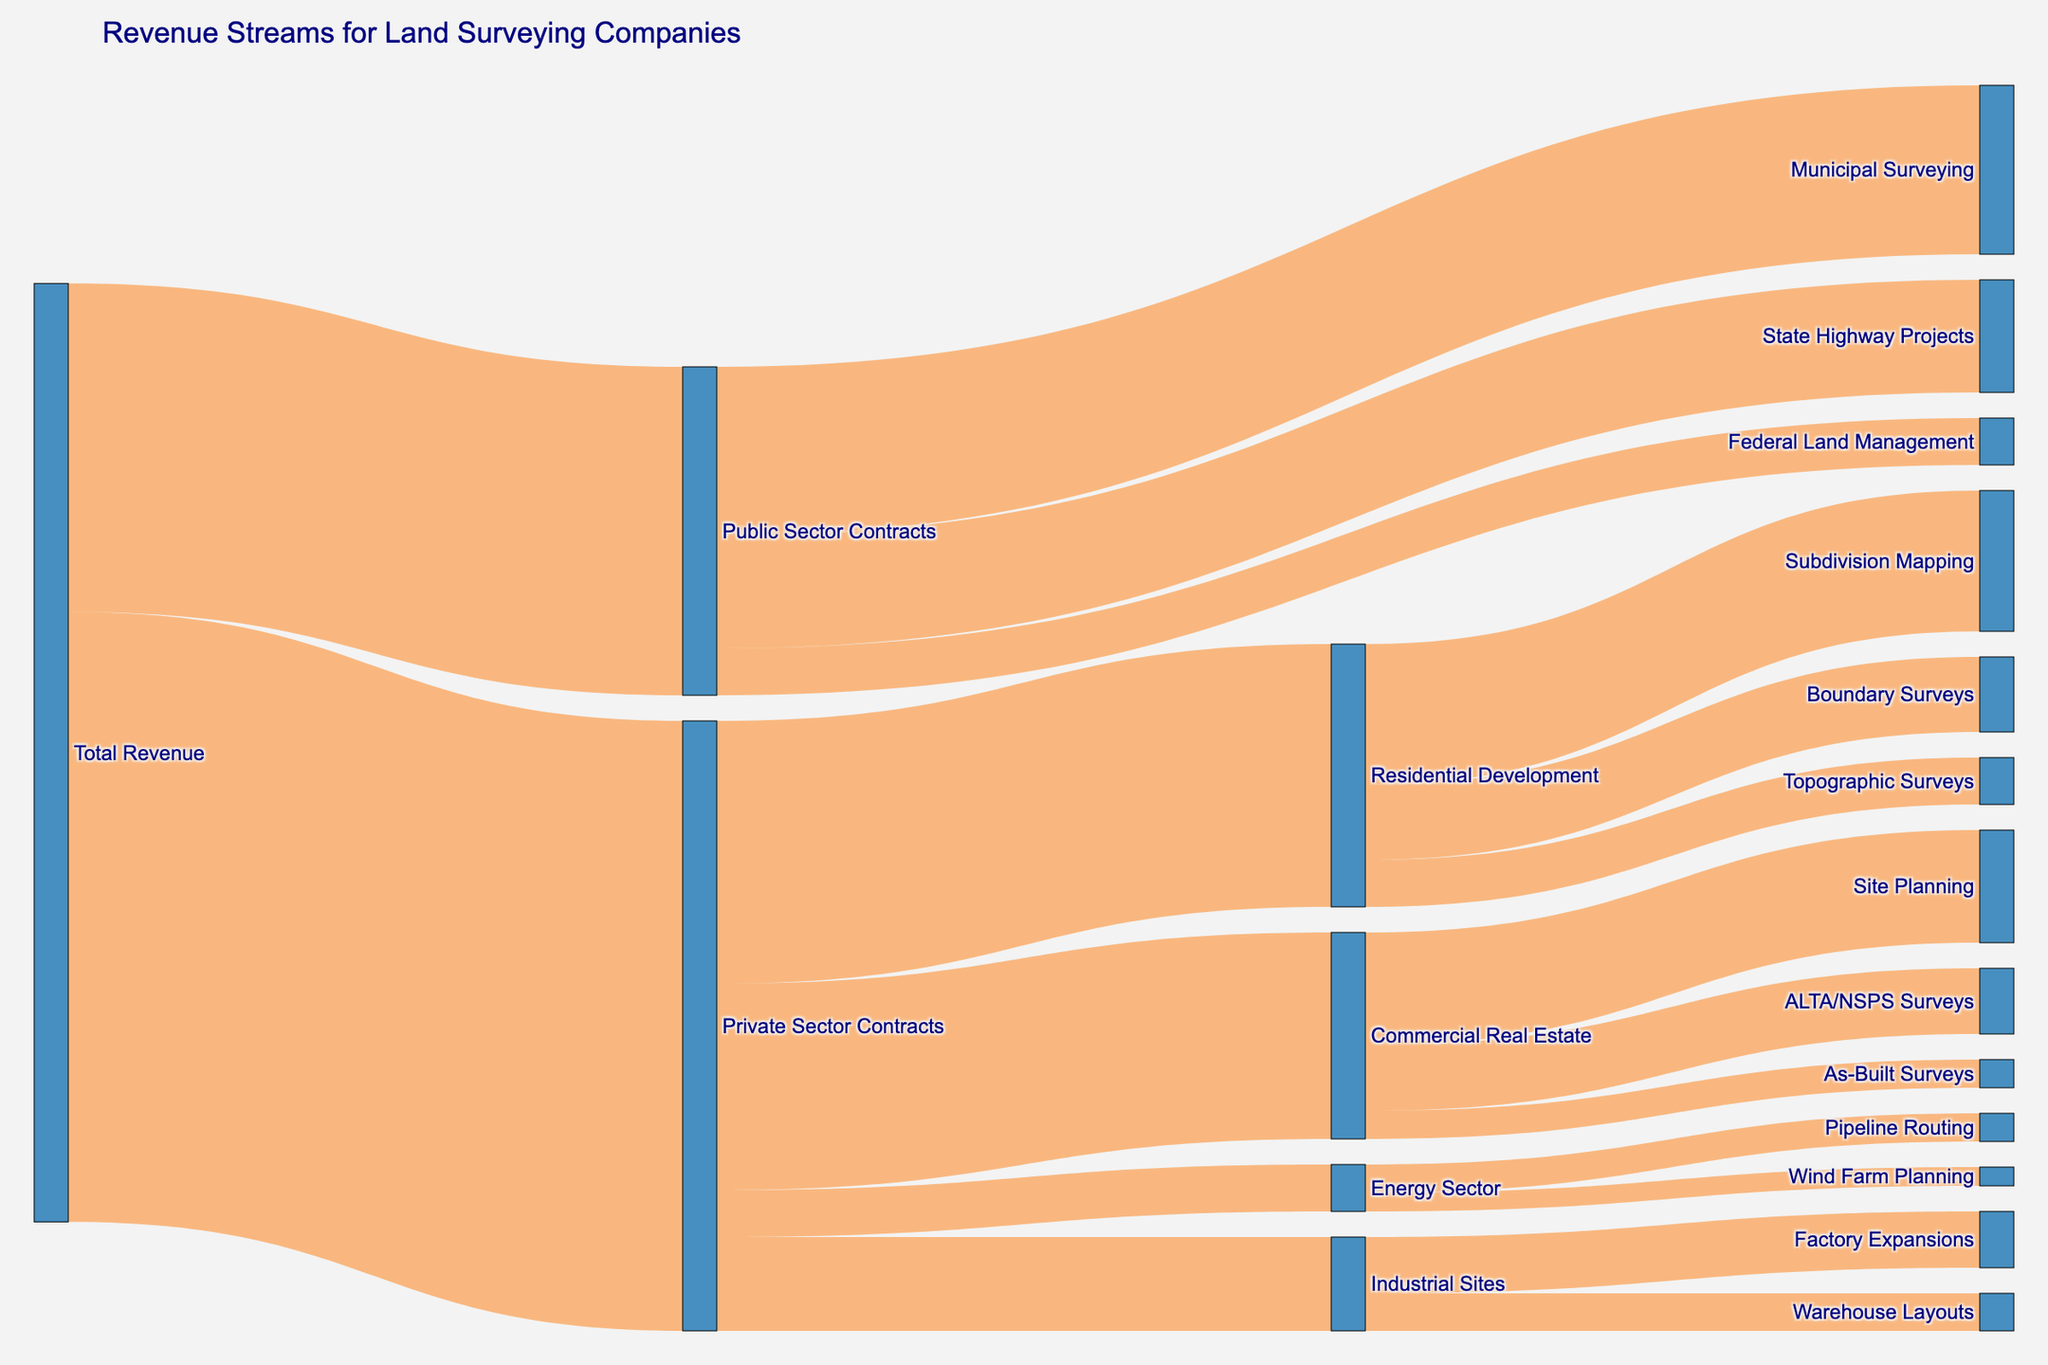How much total revenue is generated from public sector contracts? Locate the node labeled "Public Sector Contracts" and identify its associated revenue value.
Answer: 3,500,000 What percentage of the total revenue comes from private sector contracts? First, determine the value for "Private Sector Contracts" (6,500,000). Then, find the total revenue by summing "Public Sector Contracts" (3,500,000) and "Private Sector Contracts" (6,500,000), which gives 10,000,000. The percentage is then (6,500,000 / 10,000,000) * 100.
Answer: 65% Which specific activity within public sector contracts generates the most revenue? Examine the branches under "Public Sector Contracts" and compare their values: "Municipal Surveying" (1,800,000), "State Highway Projects" (1,200,000), and "Federal Land Management" (500,000).
Answer: Municipal Surveying How much total revenue is generated from the "Energy Sector"? Identify the nodes connected to "Energy Sector" and sum their values: "Pipeline Routing" (300,000) and "Wind Farm Planning" (200,000).
Answer: 500,000 Compare the revenue from "Subdivision Mapping" and "Boundary Surveys" under residential development. Which one is higher and by how much? Locate the nodes "Subdivision Mapping" (1,500,000) and "Boundary Surveys" (800,000). Subtract the smaller value from the larger one to find the difference.
Answer: Subdivision Mapping by 700,000 What is the proportion of the total revenue generated by “Commercial Real Estate” in private sector contracts? First, note the revenue for "Commercial Real Estate" (2,200,000) under "Private Sector Contracts" (6,500,000). Calculate the proportion by dividing these values: 2,200,000 / 6,500,000.
Answer: 33.85% Which has a higher revenue: "State Highway Projects" or "Factory Expansions"? Locate the nodes for "State Highway Projects" (1,200,000) and "Factory Expansions" (600,000). Compare the values.
Answer: State Highway Projects What is the total revenue generated from all "Commercial Real Estate" activities? Sum values under "Commercial Real Estate": "Site Planning" (1,200,000), "ALTA/NSPS Surveys" (700,000), and "As-Built Surveys" (300,000).
Answer: 2,200,000 How do the revenues from "Wind Farm Planning" compare to "Pipeline Routing" in the energy sector? Check the nodes under "Energy Sector": "Wind Farm Planning" (200,000) and "Pipeline Routing" (300,000). Compare the two.
Answer: Pipeline Routing is higher by 100,000 Identify the smallest revenue source in the public sector. Check values for "Municipal Surveying" (1,800,000), "State Highway Projects" (1,200,000), and "Federal Land Management" (500,000).
Answer: Federal Land Management 